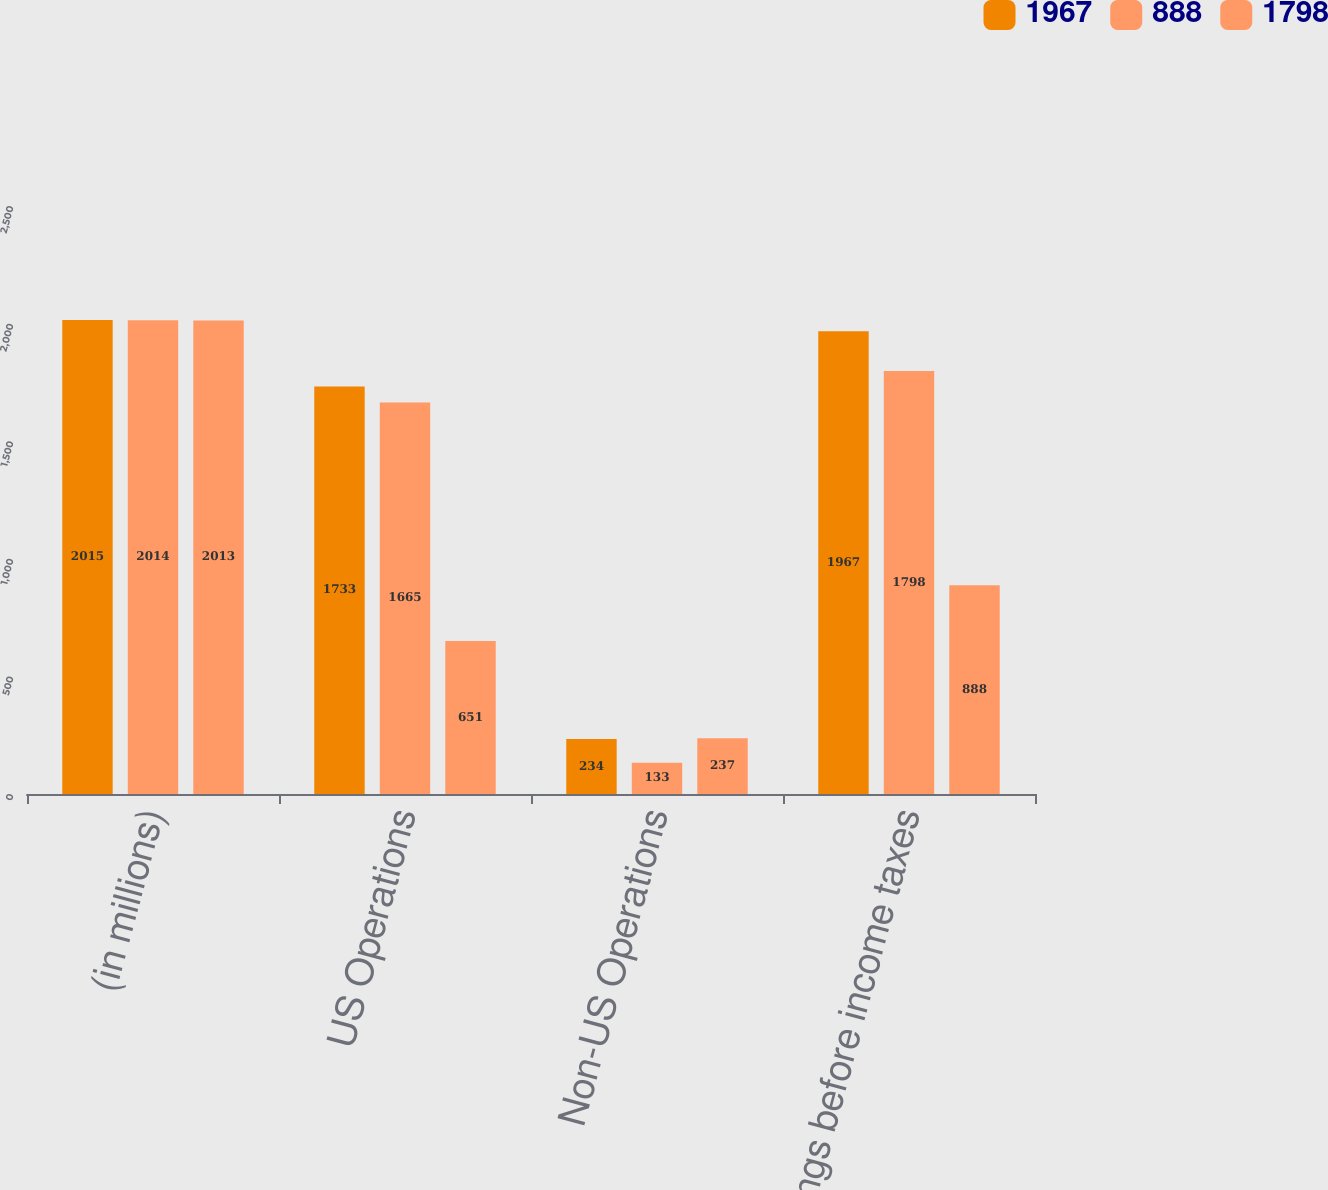Convert chart. <chart><loc_0><loc_0><loc_500><loc_500><stacked_bar_chart><ecel><fcel>(in millions)<fcel>US Operations<fcel>Non-US Operations<fcel>Earnings before income taxes<nl><fcel>1967<fcel>2015<fcel>1733<fcel>234<fcel>1967<nl><fcel>888<fcel>2014<fcel>1665<fcel>133<fcel>1798<nl><fcel>1798<fcel>2013<fcel>651<fcel>237<fcel>888<nl></chart> 